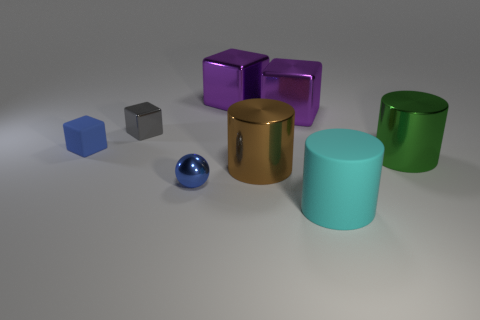Can you describe the lighting in the scene? Does it appear to be natural or artificial? The lighting in the scene appears artificial, as it is soft and evenly distributed across the objects. There are no harsh shadows or direct light sources like the sun visible, which typically indicate natural lighting. What time of day would this lighting be comparable to if it were natural? If we were to compare this soft and even artificial lighting to natural conditions, it would be similar to an overcast day where the sky is cloudy, and sunlight is diffused, reducing shadows and glare. 